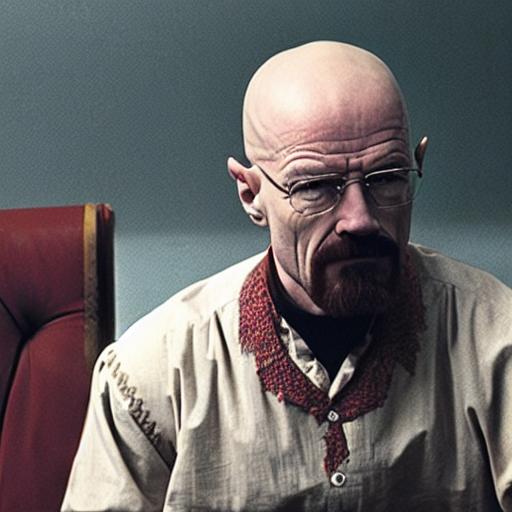What does the background consist of?
A. Blue-gray blocks.
B. Detailed elements
C. Colorful patterns
Answer with the option's letter from the given choices directly.
 A. 